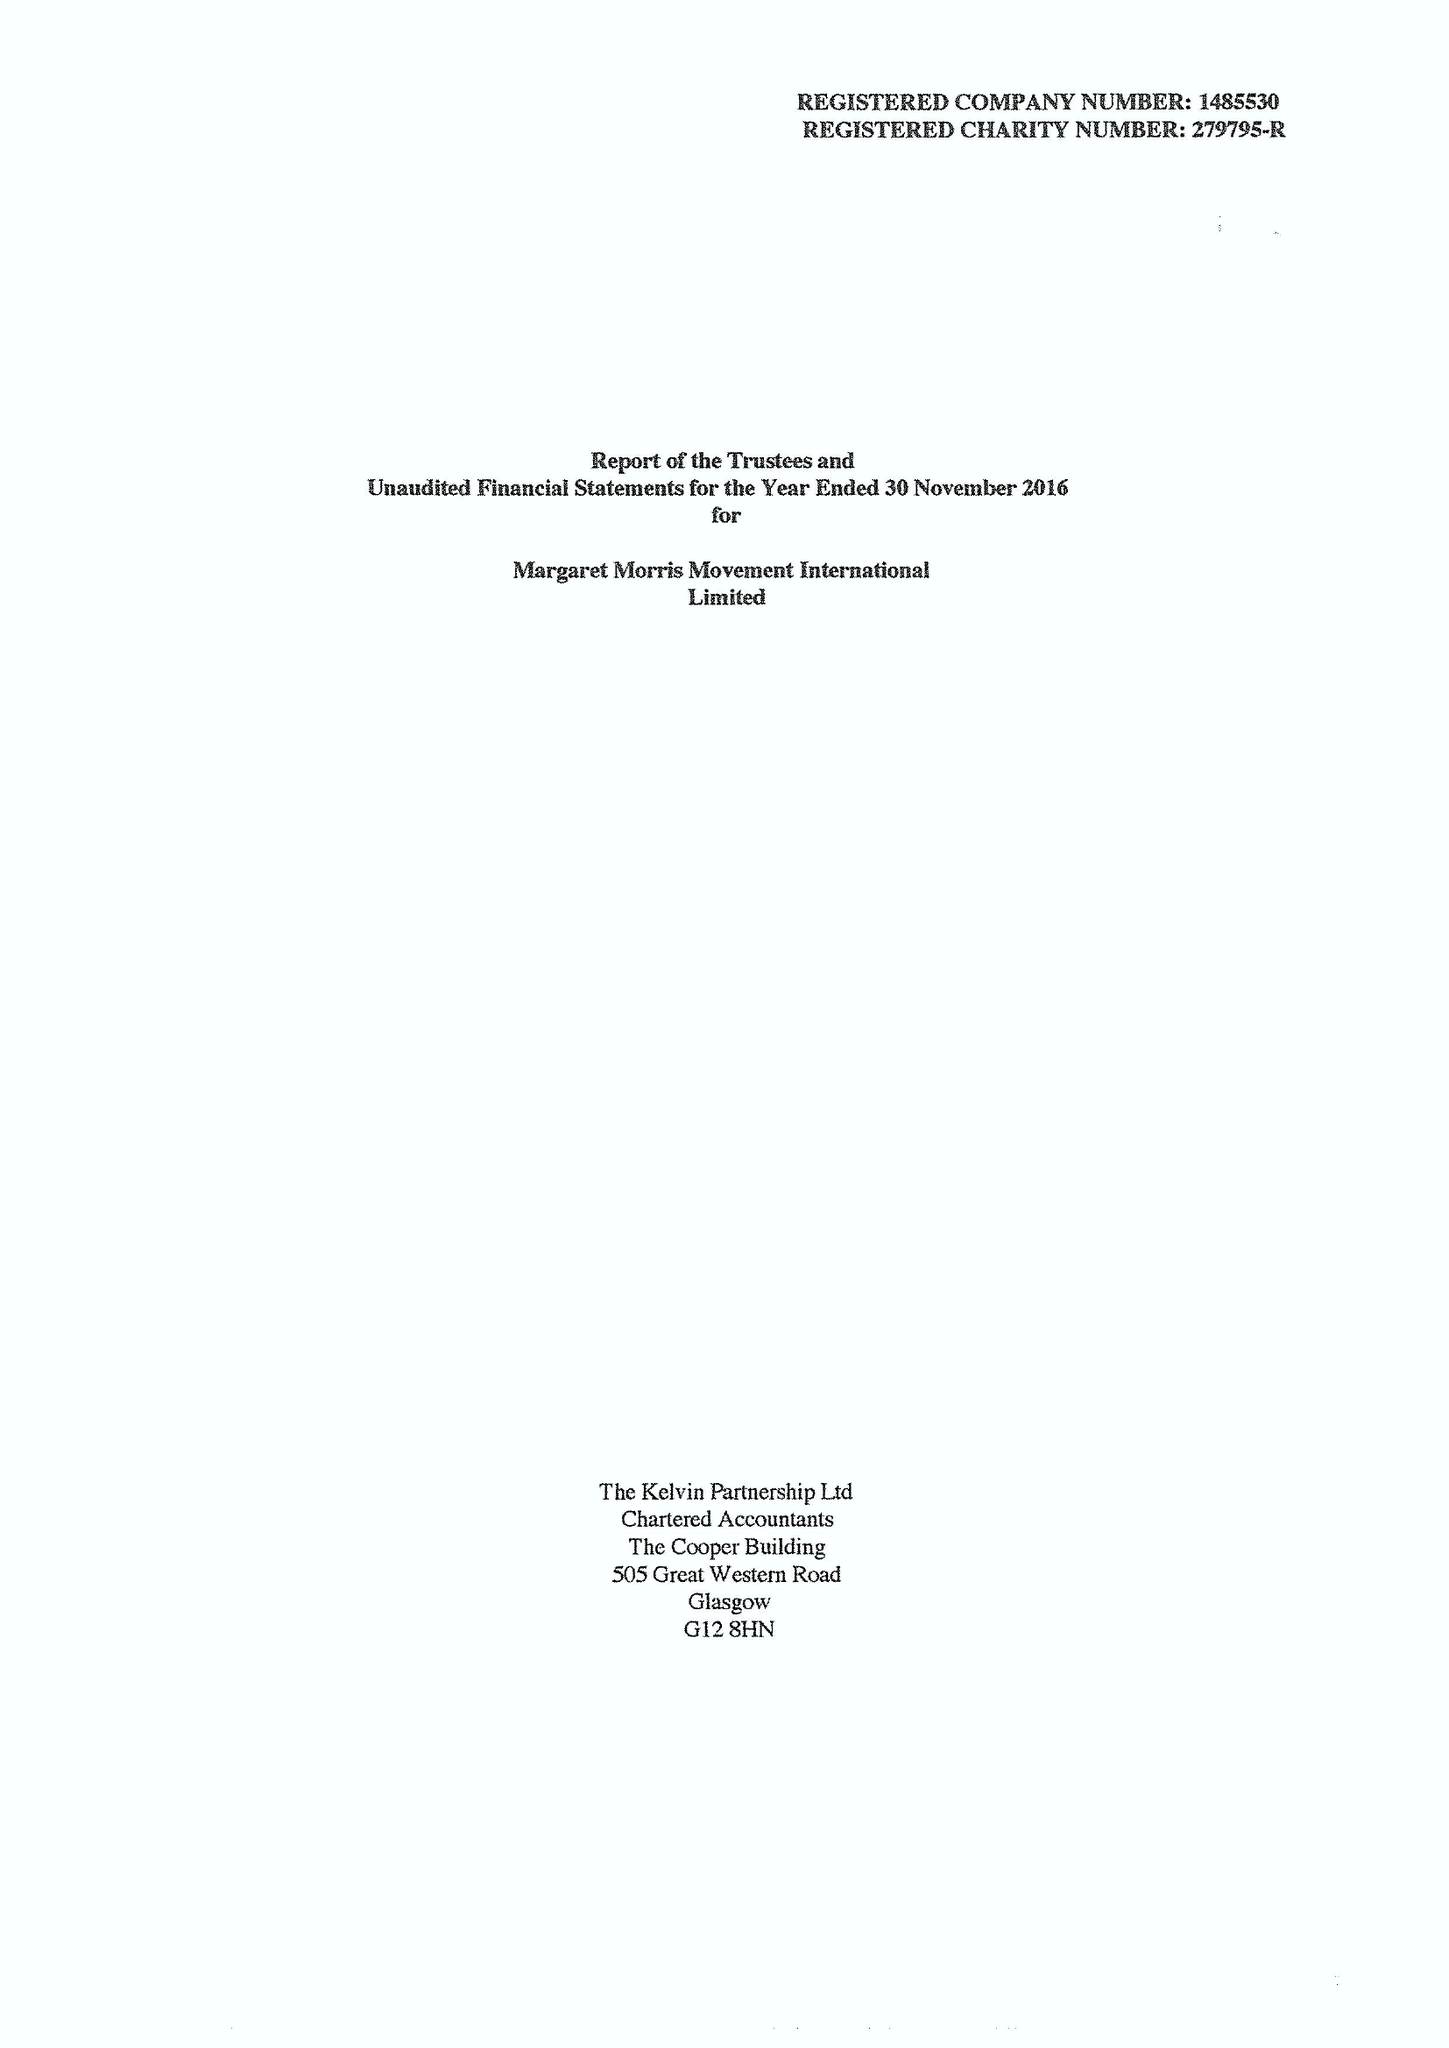What is the value for the address__postcode?
Answer the question using a single word or phrase. TF8 7DA 